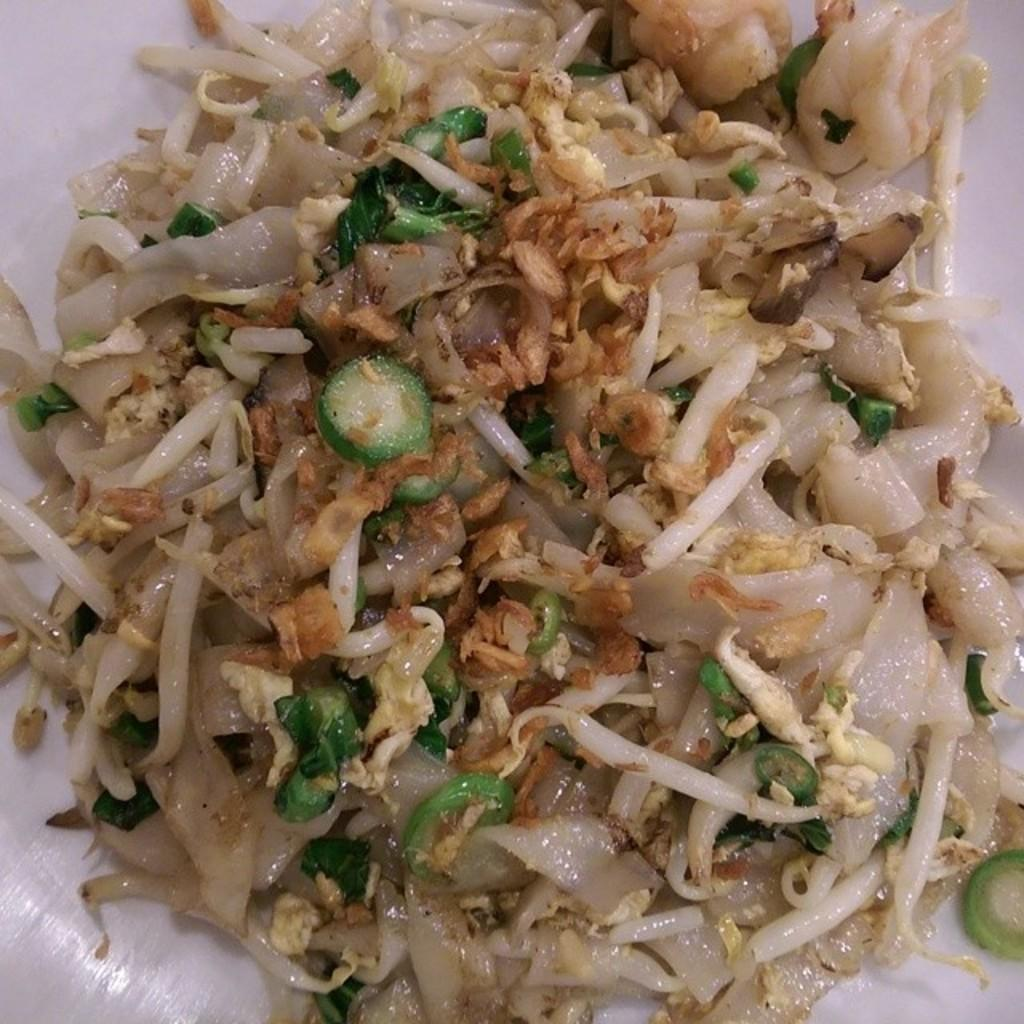What is present in the image? There is food in the image. What can be inferred about the food's location? The food is placed on a white object. Is there a crown visible on the food in the image? No, there is no crown present in the image. 